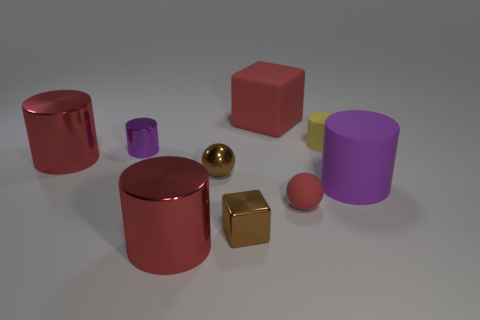Subtract all gray cubes. How many red cylinders are left? 2 Subtract all yellow rubber cylinders. How many cylinders are left? 4 Subtract all red cylinders. How many cylinders are left? 3 Subtract all yellow cylinders. Subtract all gray blocks. How many cylinders are left? 4 Add 1 red objects. How many objects exist? 10 Subtract all balls. How many objects are left? 7 Subtract 0 yellow spheres. How many objects are left? 9 Subtract all tiny brown shiny spheres. Subtract all large matte blocks. How many objects are left? 7 Add 7 large blocks. How many large blocks are left? 8 Add 1 red matte balls. How many red matte balls exist? 2 